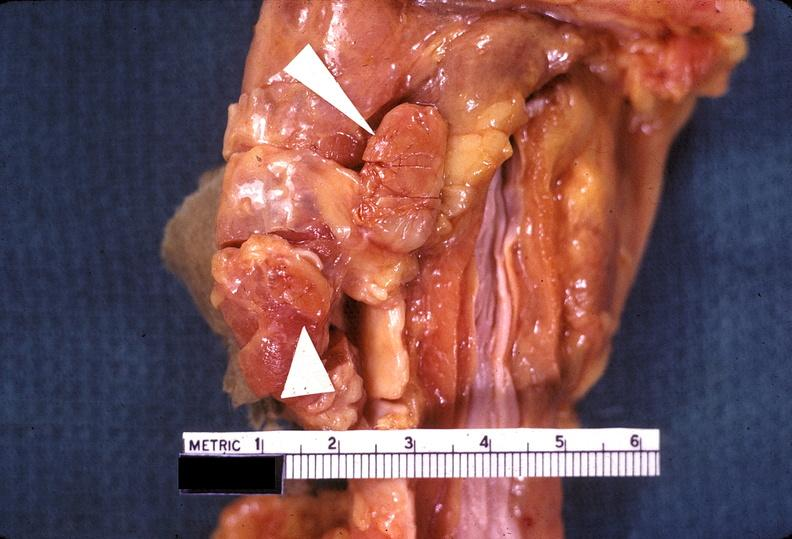does fibrinous peritonitis show parathyroid hyperplasia?
Answer the question using a single word or phrase. No 